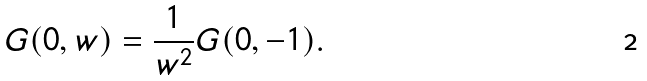<formula> <loc_0><loc_0><loc_500><loc_500>G ( 0 , w ) = \frac { 1 } { w ^ { 2 } } G ( 0 , - 1 ) .</formula> 